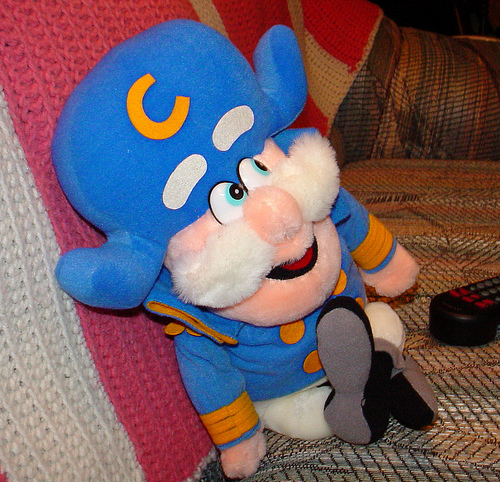<image>
Is there a captain crunch to the left of the remote? Yes. From this viewpoint, the captain crunch is positioned to the left side relative to the remote. 